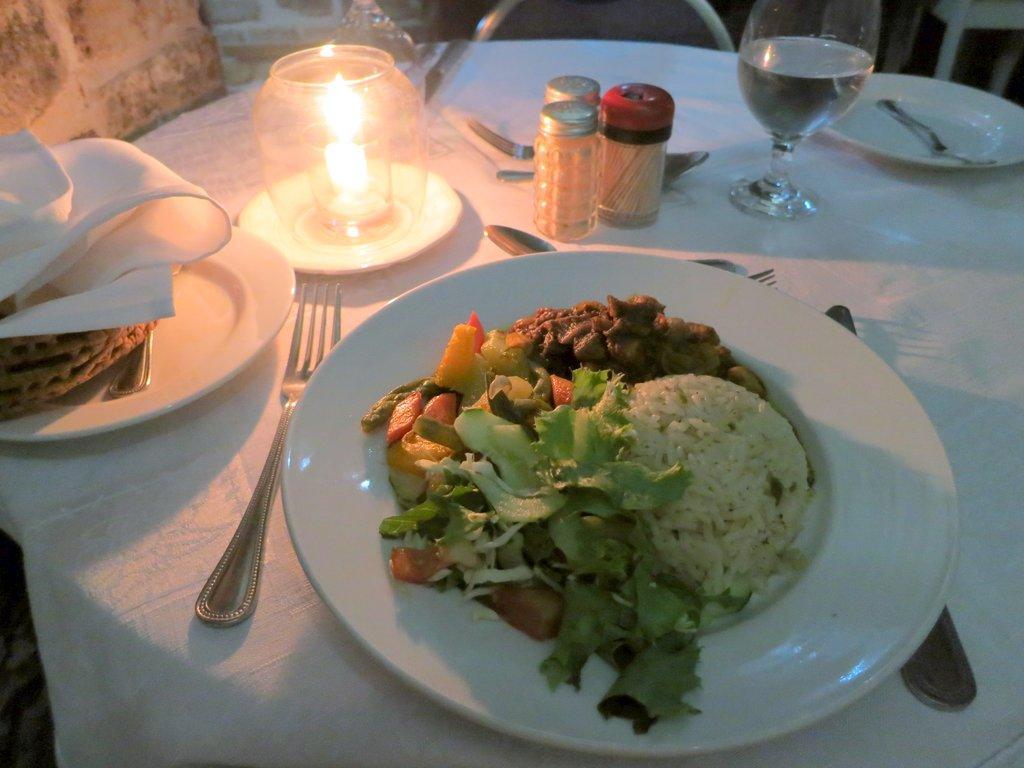In one or two sentences, can you explain what this image depicts? In this picture we can see a table in the front, there are plates, a candle, a glass of water, forks and knives present on the table, we can see some food in this plate, we can see a cloth on the table. 